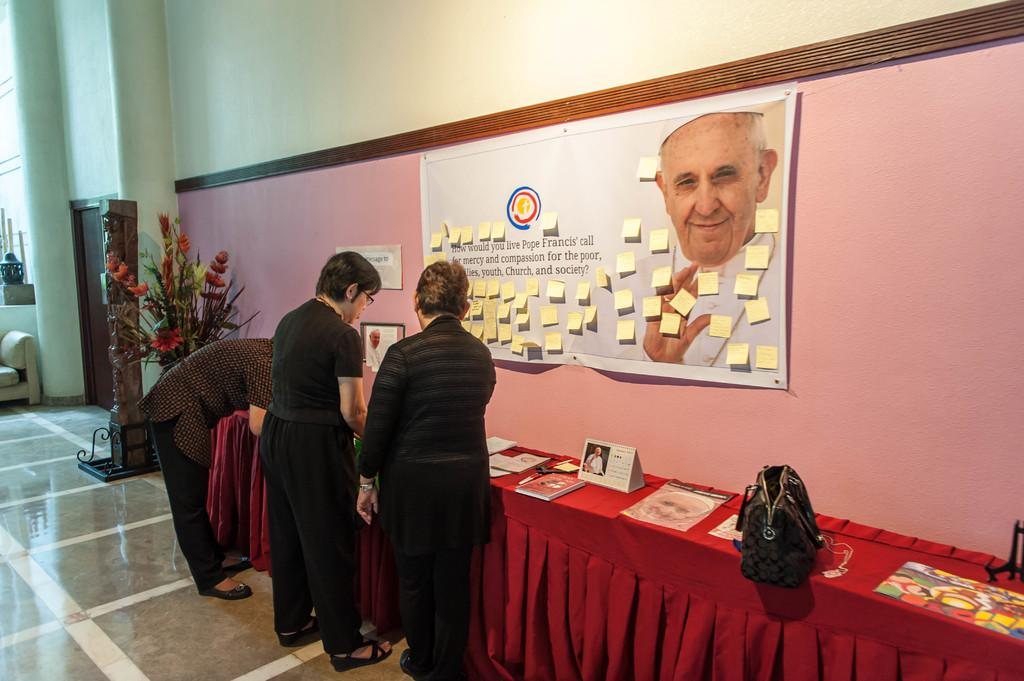How many people are present in the image? There are three persons standing in the image. What objects can be seen on the table? There are books and a bag on the table. What is hanging on the wall? There is a banner on a wall. Can you describe a small object in the image? There is a small flower pot in the image. What architectural feature is present in the image? There is a door in the image. What type of surface is visible in the image? There is a wall in the image. What type of force can be seen pushing the books off the table in the image? There is no force pushing the books off the table in the image; they are resting on the table. Can you describe the flock of birds flying through the room in the image? There are no birds, flock or otherwise, present in the image. 